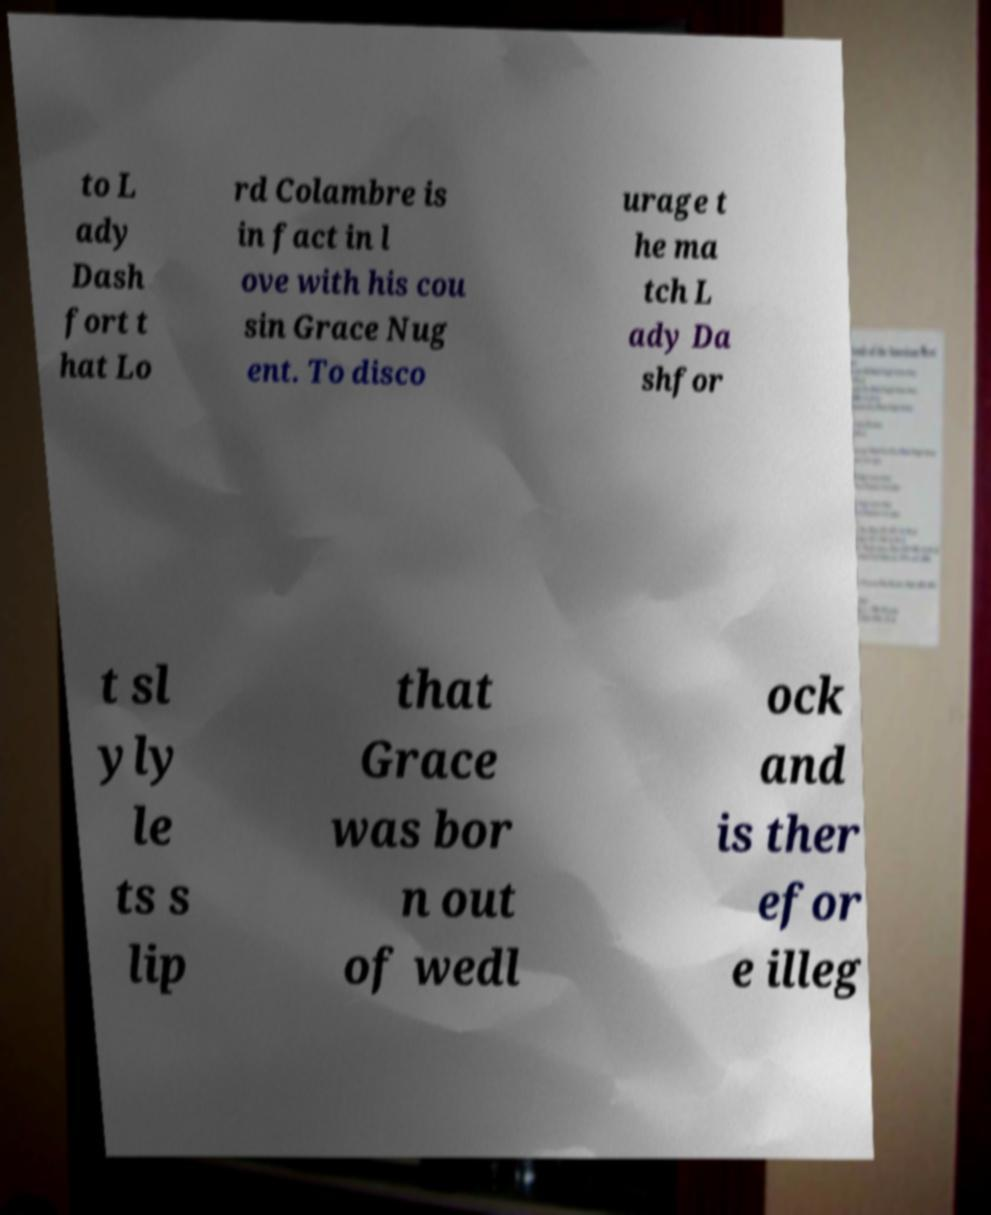There's text embedded in this image that I need extracted. Can you transcribe it verbatim? to L ady Dash fort t hat Lo rd Colambre is in fact in l ove with his cou sin Grace Nug ent. To disco urage t he ma tch L ady Da shfor t sl yly le ts s lip that Grace was bor n out of wedl ock and is ther efor e illeg 